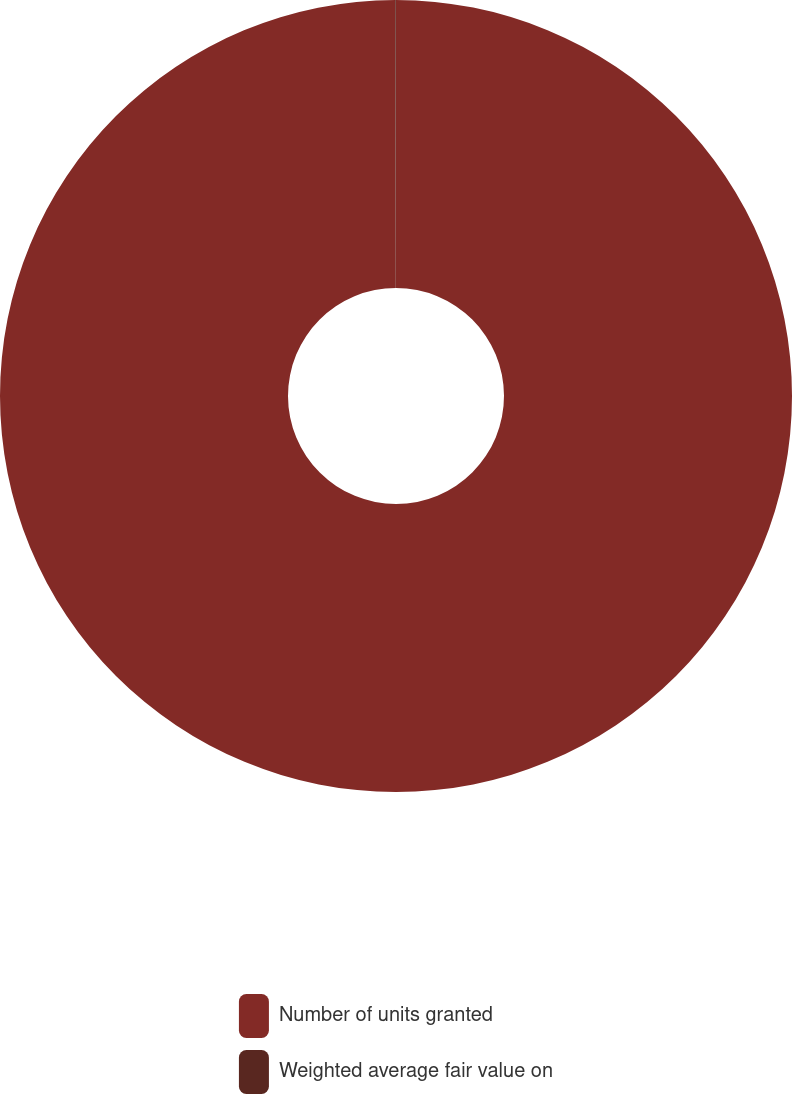Convert chart. <chart><loc_0><loc_0><loc_500><loc_500><pie_chart><fcel>Number of units granted<fcel>Weighted average fair value on<nl><fcel>99.97%<fcel>0.03%<nl></chart> 